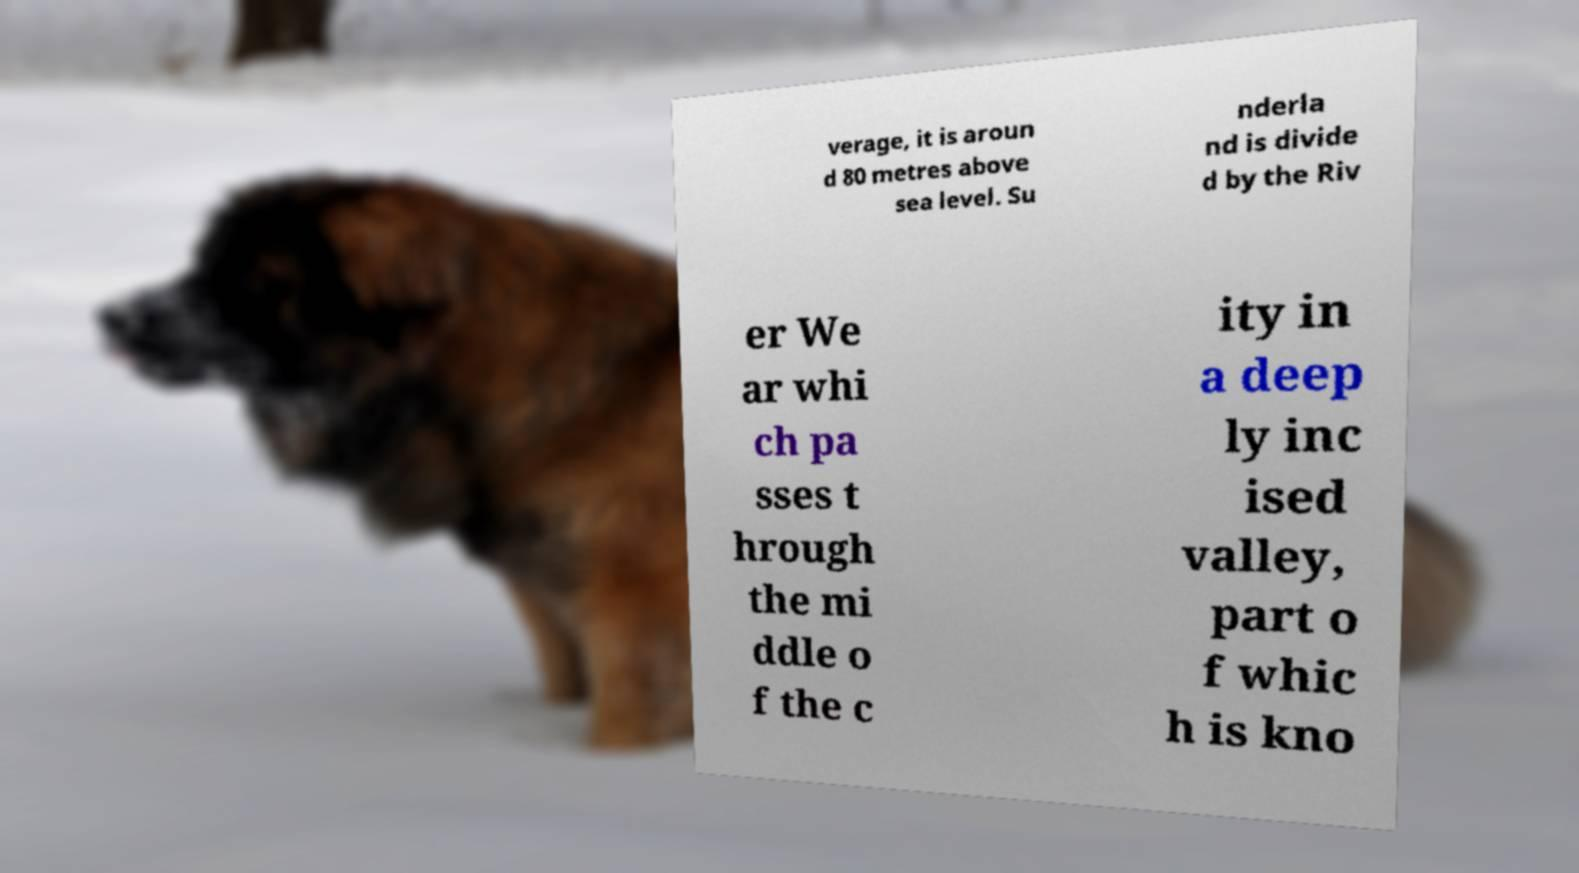There's text embedded in this image that I need extracted. Can you transcribe it verbatim? verage, it is aroun d 80 metres above sea level. Su nderla nd is divide d by the Riv er We ar whi ch pa sses t hrough the mi ddle o f the c ity in a deep ly inc ised valley, part o f whic h is kno 